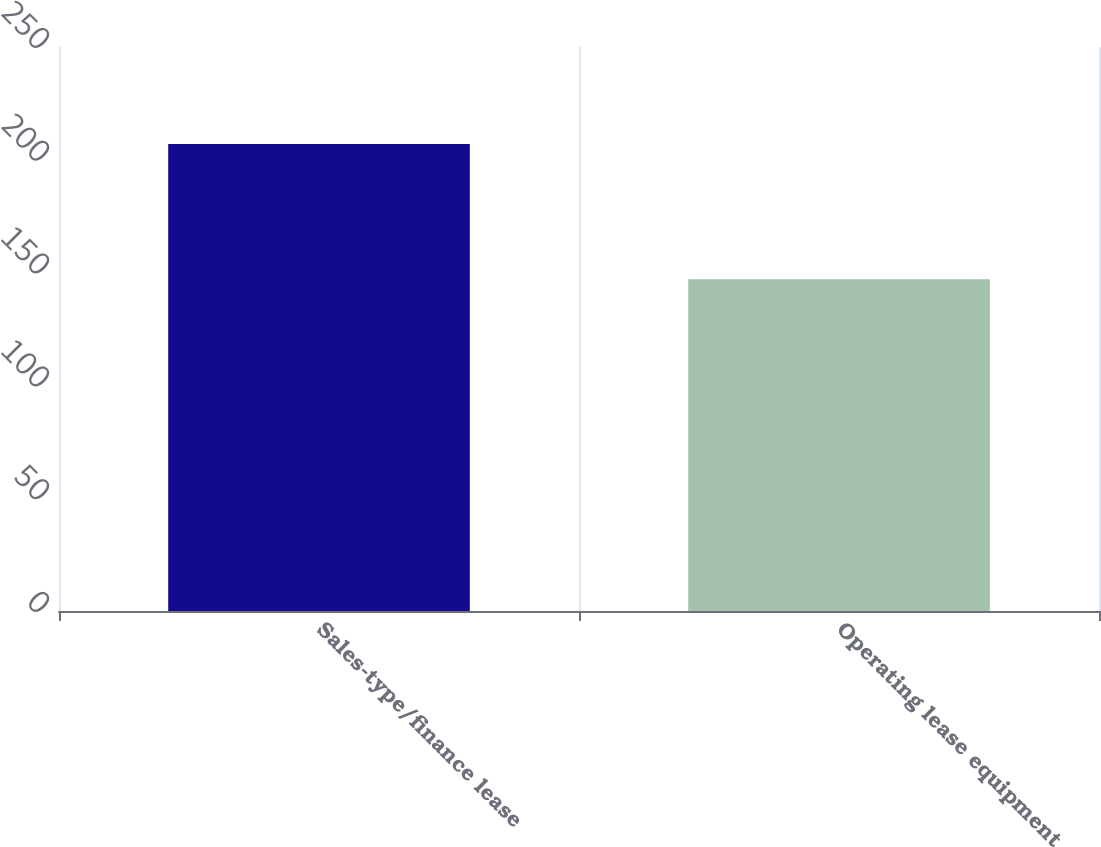Convert chart to OTSL. <chart><loc_0><loc_0><loc_500><loc_500><bar_chart><fcel>Sales-type/finance lease<fcel>Operating lease equipment<nl><fcel>207<fcel>147<nl></chart> 